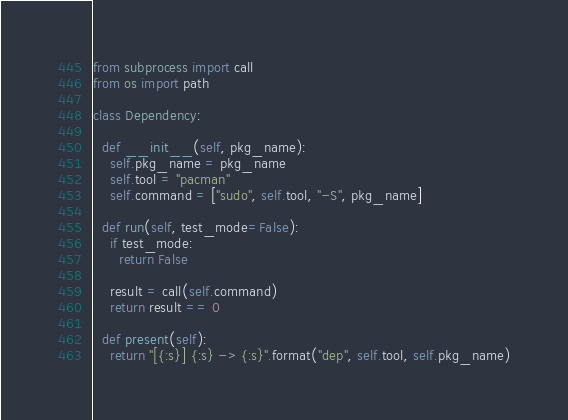<code> <loc_0><loc_0><loc_500><loc_500><_Python_>from subprocess import call
from os import path

class Dependency:

  def __init__(self, pkg_name):
    self.pkg_name = pkg_name
    self.tool = "pacman"
    self.command = ["sudo", self.tool, "-S", pkg_name]

  def run(self, test_mode=False):
    if test_mode:
      return False

    result = call(self.command)
    return result == 0

  def present(self):
    return "[{:s}] {:s} -> {:s}".format("dep", self.tool, self.pkg_name)

</code> 